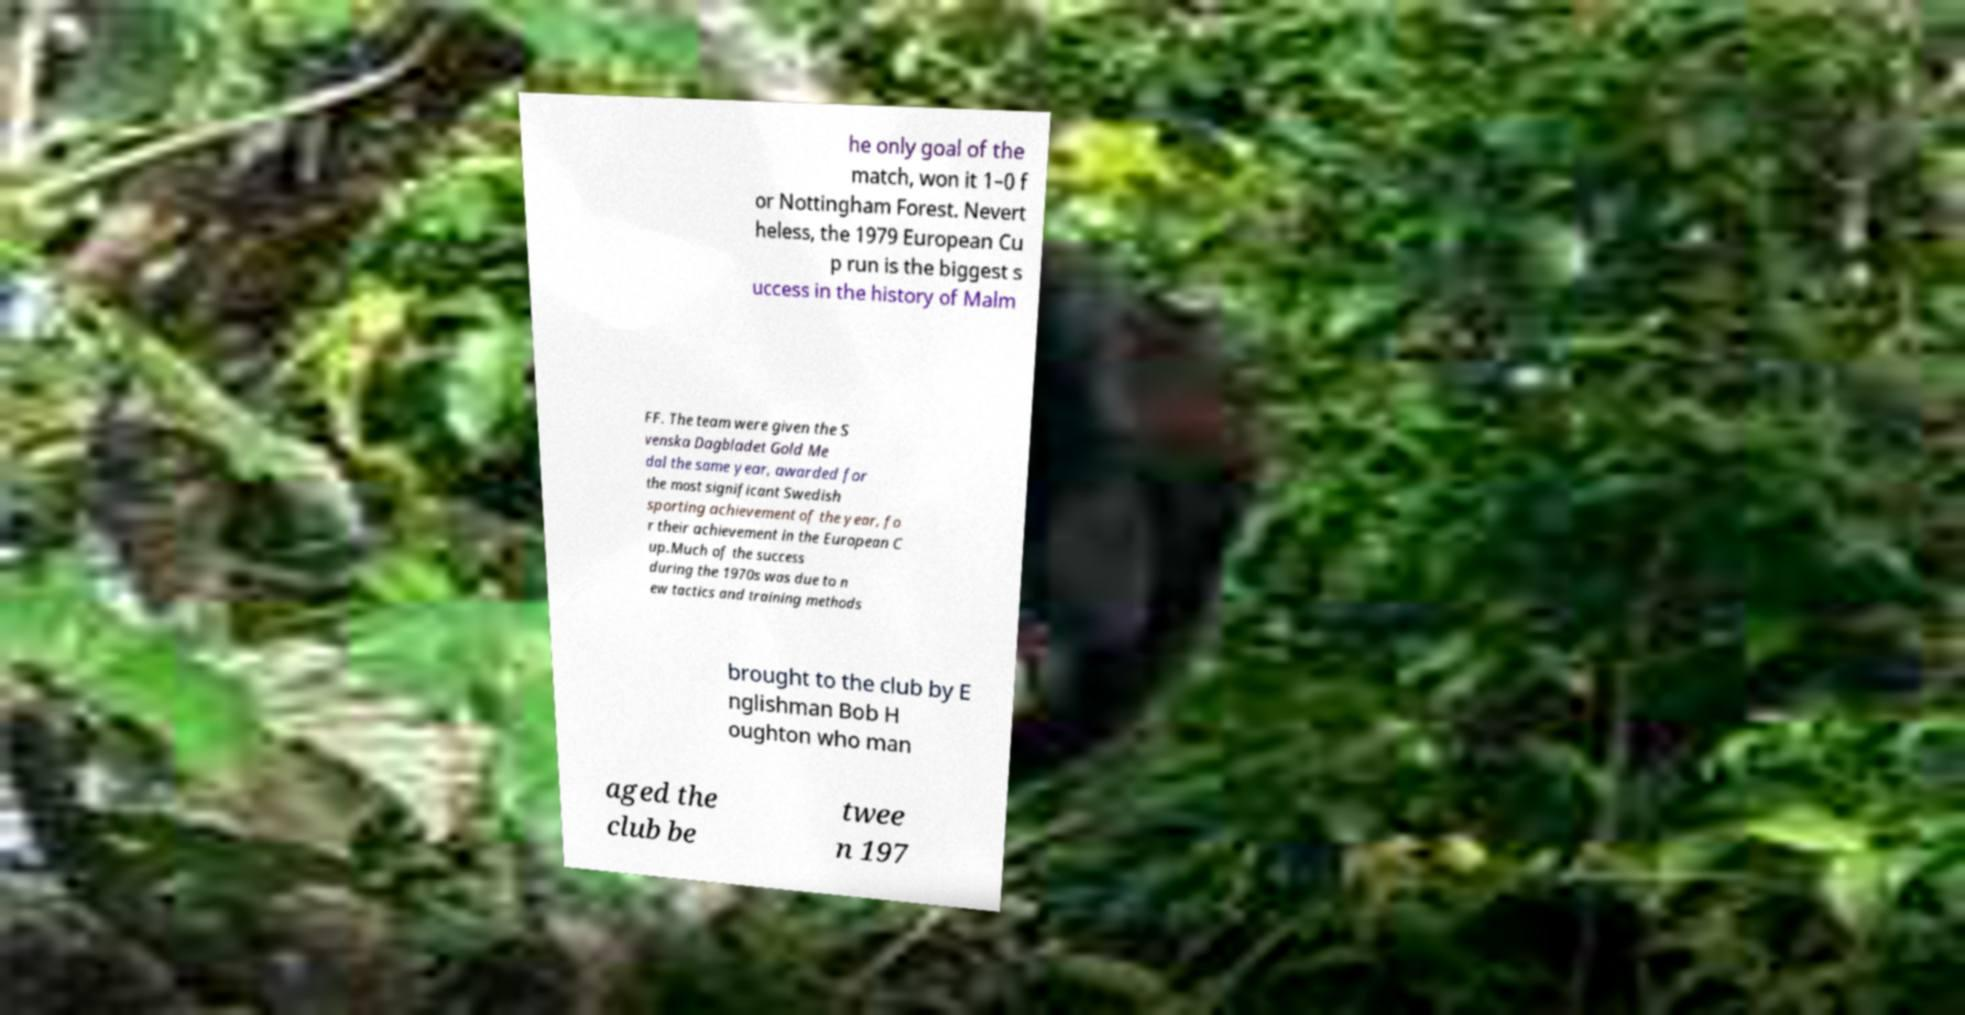Can you read and provide the text displayed in the image?This photo seems to have some interesting text. Can you extract and type it out for me? he only goal of the match, won it 1–0 f or Nottingham Forest. Nevert heless, the 1979 European Cu p run is the biggest s uccess in the history of Malm FF. The team were given the S venska Dagbladet Gold Me dal the same year, awarded for the most significant Swedish sporting achievement of the year, fo r their achievement in the European C up.Much of the success during the 1970s was due to n ew tactics and training methods brought to the club by E nglishman Bob H oughton who man aged the club be twee n 197 